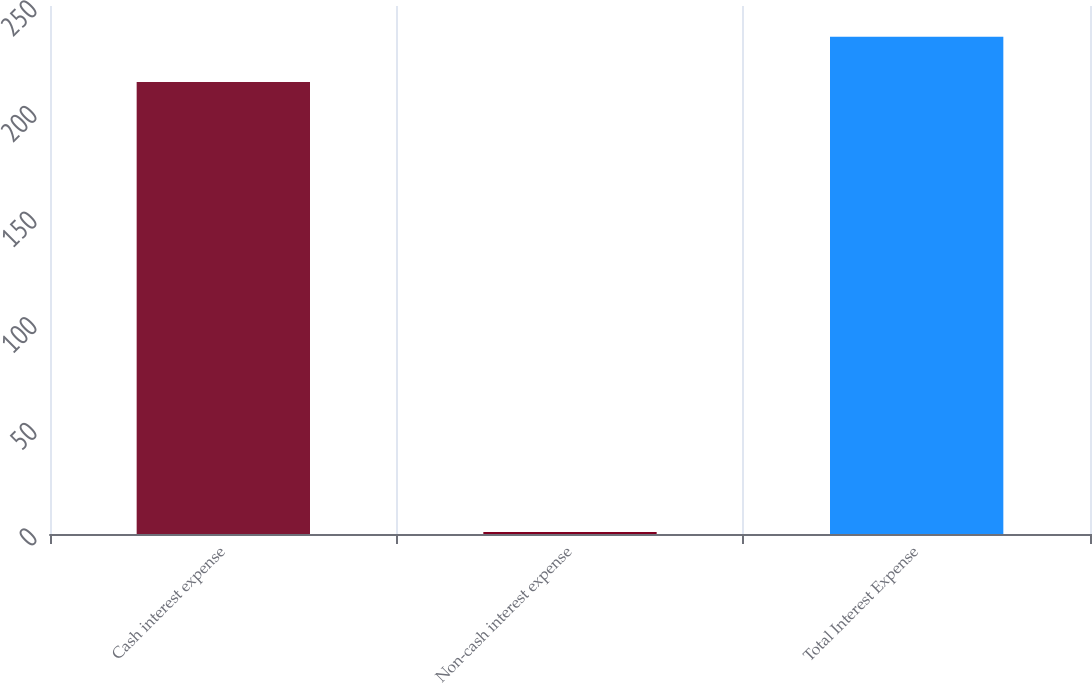<chart> <loc_0><loc_0><loc_500><loc_500><bar_chart><fcel>Cash interest expense<fcel>Non-cash interest expense<fcel>Total Interest Expense<nl><fcel>214<fcel>1<fcel>235.4<nl></chart> 